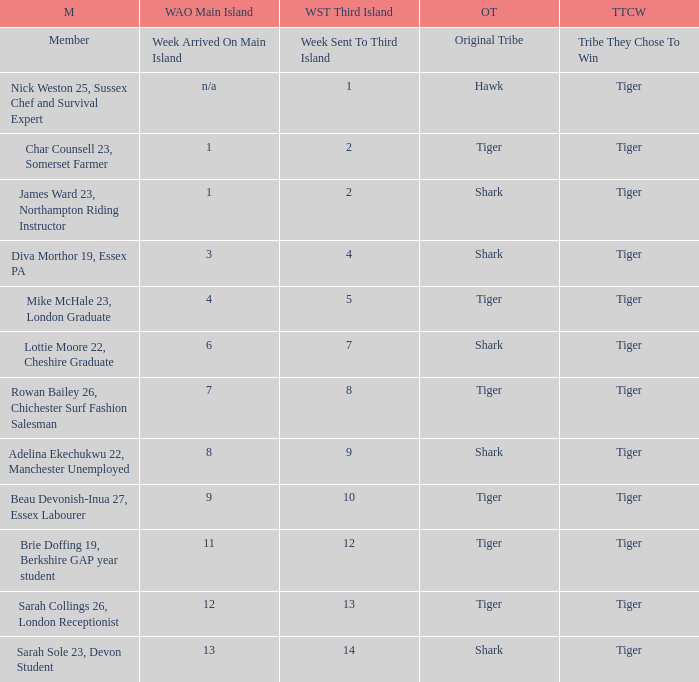What week was the member who arrived on the main island in week 6 sent to the third island? 7.0. 